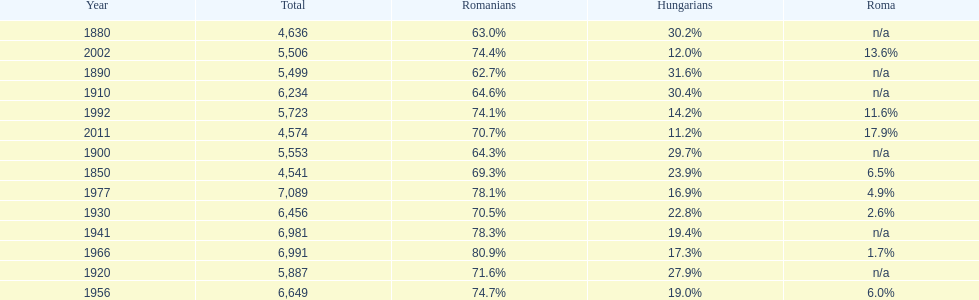What year had the highest total number? 1977. 